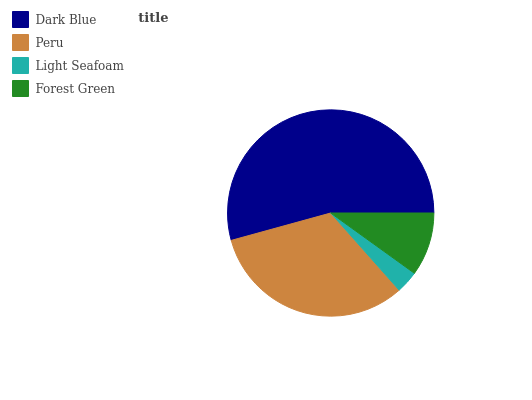Is Light Seafoam the minimum?
Answer yes or no. Yes. Is Dark Blue the maximum?
Answer yes or no. Yes. Is Peru the minimum?
Answer yes or no. No. Is Peru the maximum?
Answer yes or no. No. Is Dark Blue greater than Peru?
Answer yes or no. Yes. Is Peru less than Dark Blue?
Answer yes or no. Yes. Is Peru greater than Dark Blue?
Answer yes or no. No. Is Dark Blue less than Peru?
Answer yes or no. No. Is Peru the high median?
Answer yes or no. Yes. Is Forest Green the low median?
Answer yes or no. Yes. Is Dark Blue the high median?
Answer yes or no. No. Is Light Seafoam the low median?
Answer yes or no. No. 